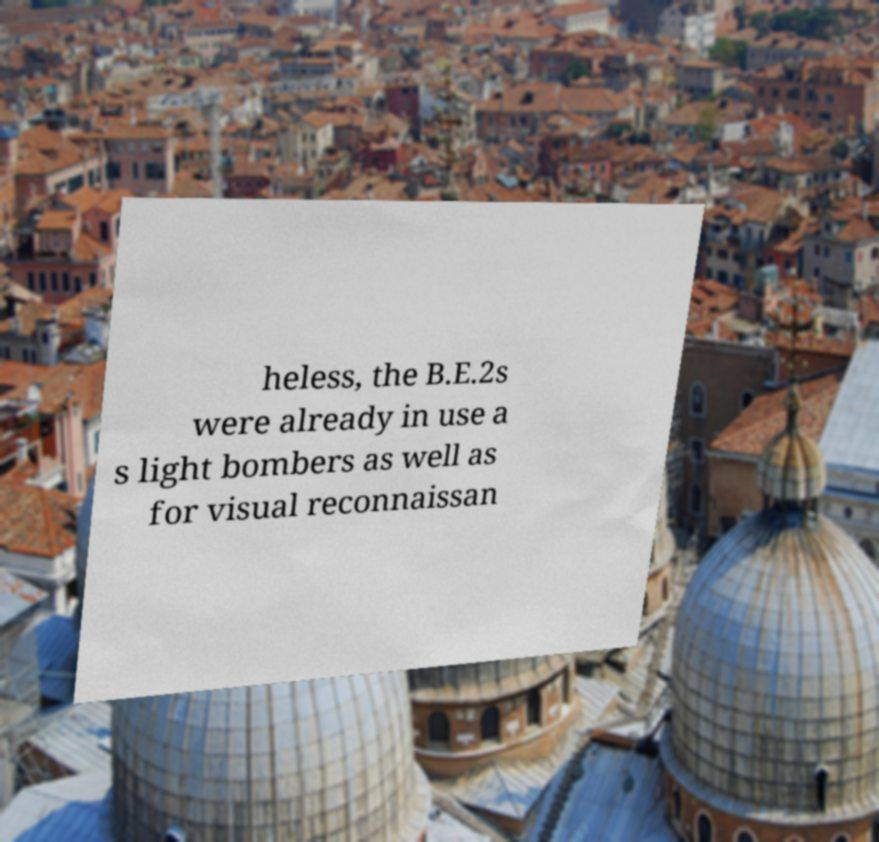Could you extract and type out the text from this image? heless, the B.E.2s were already in use a s light bombers as well as for visual reconnaissan 